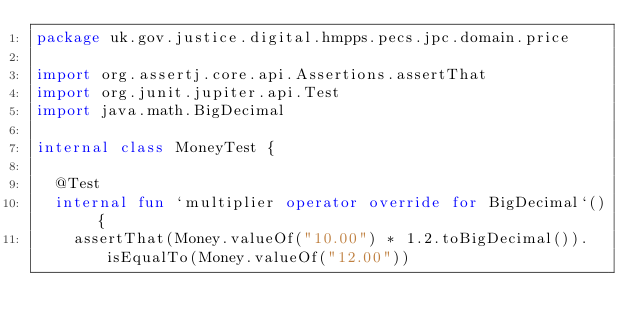Convert code to text. <code><loc_0><loc_0><loc_500><loc_500><_Kotlin_>package uk.gov.justice.digital.hmpps.pecs.jpc.domain.price

import org.assertj.core.api.Assertions.assertThat
import org.junit.jupiter.api.Test
import java.math.BigDecimal

internal class MoneyTest {

  @Test
  internal fun `multiplier operator override for BigDecimal`() {
    assertThat(Money.valueOf("10.00") * 1.2.toBigDecimal()).isEqualTo(Money.valueOf("12.00"))</code> 